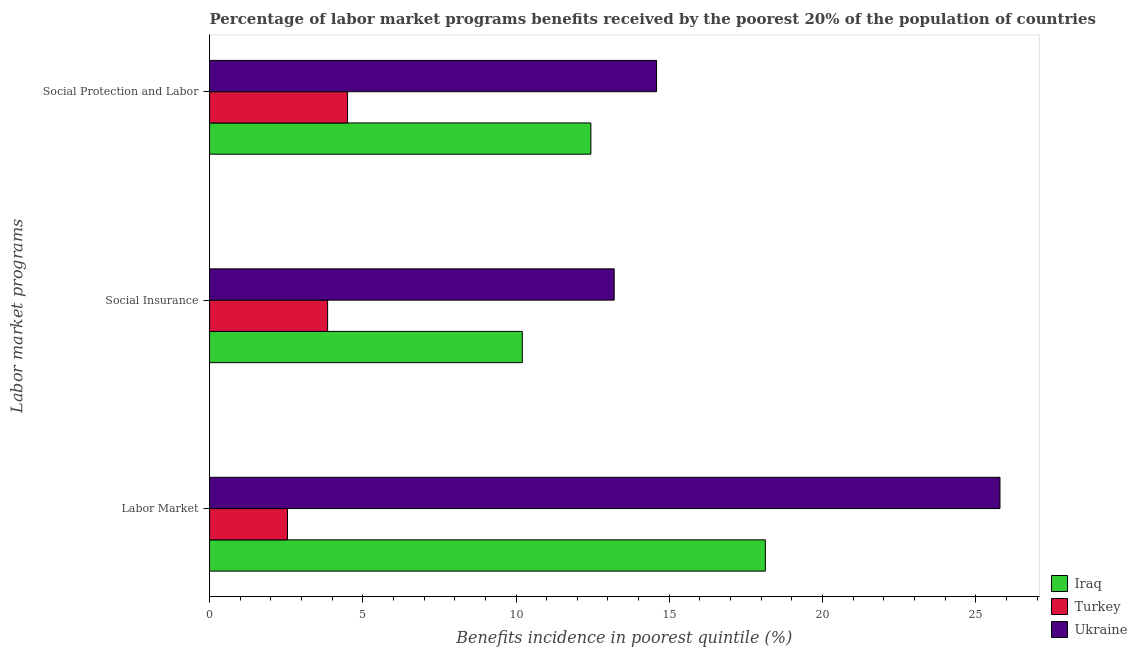How many different coloured bars are there?
Ensure brevity in your answer.  3. Are the number of bars per tick equal to the number of legend labels?
Offer a very short reply. Yes. Are the number of bars on each tick of the Y-axis equal?
Give a very brief answer. Yes. How many bars are there on the 1st tick from the top?
Your answer should be very brief. 3. What is the label of the 2nd group of bars from the top?
Your answer should be compact. Social Insurance. What is the percentage of benefits received due to social insurance programs in Ukraine?
Make the answer very short. 13.2. Across all countries, what is the maximum percentage of benefits received due to social insurance programs?
Provide a short and direct response. 13.2. Across all countries, what is the minimum percentage of benefits received due to labor market programs?
Provide a succinct answer. 2.54. In which country was the percentage of benefits received due to social insurance programs maximum?
Provide a short and direct response. Ukraine. In which country was the percentage of benefits received due to social insurance programs minimum?
Your response must be concise. Turkey. What is the total percentage of benefits received due to labor market programs in the graph?
Your answer should be compact. 46.47. What is the difference between the percentage of benefits received due to social protection programs in Iraq and that in Turkey?
Your response must be concise. 7.94. What is the difference between the percentage of benefits received due to labor market programs in Ukraine and the percentage of benefits received due to social insurance programs in Iraq?
Ensure brevity in your answer.  15.59. What is the average percentage of benefits received due to social insurance programs per country?
Provide a succinct answer. 9.09. What is the difference between the percentage of benefits received due to social insurance programs and percentage of benefits received due to social protection programs in Iraq?
Ensure brevity in your answer.  -2.24. In how many countries, is the percentage of benefits received due to social protection programs greater than 26 %?
Make the answer very short. 0. What is the ratio of the percentage of benefits received due to social insurance programs in Iraq to that in Ukraine?
Your answer should be compact. 0.77. Is the percentage of benefits received due to social protection programs in Turkey less than that in Ukraine?
Your answer should be very brief. Yes. Is the difference between the percentage of benefits received due to social protection programs in Ukraine and Iraq greater than the difference between the percentage of benefits received due to social insurance programs in Ukraine and Iraq?
Your response must be concise. No. What is the difference between the highest and the second highest percentage of benefits received due to labor market programs?
Your answer should be very brief. 7.65. What is the difference between the highest and the lowest percentage of benefits received due to social protection programs?
Offer a terse response. 10.08. What does the 1st bar from the top in Labor Market represents?
Provide a short and direct response. Ukraine. How many bars are there?
Offer a terse response. 9. Are all the bars in the graph horizontal?
Offer a terse response. Yes. Does the graph contain any zero values?
Keep it short and to the point. No. Where does the legend appear in the graph?
Offer a very short reply. Bottom right. How are the legend labels stacked?
Your answer should be very brief. Vertical. What is the title of the graph?
Your answer should be very brief. Percentage of labor market programs benefits received by the poorest 20% of the population of countries. What is the label or title of the X-axis?
Offer a terse response. Benefits incidence in poorest quintile (%). What is the label or title of the Y-axis?
Make the answer very short. Labor market programs. What is the Benefits incidence in poorest quintile (%) of Iraq in Labor Market?
Offer a terse response. 18.14. What is the Benefits incidence in poorest quintile (%) of Turkey in Labor Market?
Keep it short and to the point. 2.54. What is the Benefits incidence in poorest quintile (%) in Ukraine in Labor Market?
Provide a short and direct response. 25.79. What is the Benefits incidence in poorest quintile (%) of Iraq in Social Insurance?
Offer a terse response. 10.21. What is the Benefits incidence in poorest quintile (%) of Turkey in Social Insurance?
Give a very brief answer. 3.85. What is the Benefits incidence in poorest quintile (%) in Ukraine in Social Insurance?
Provide a succinct answer. 13.2. What is the Benefits incidence in poorest quintile (%) of Iraq in Social Protection and Labor?
Ensure brevity in your answer.  12.44. What is the Benefits incidence in poorest quintile (%) of Turkey in Social Protection and Labor?
Your response must be concise. 4.5. What is the Benefits incidence in poorest quintile (%) in Ukraine in Social Protection and Labor?
Your response must be concise. 14.59. Across all Labor market programs, what is the maximum Benefits incidence in poorest quintile (%) of Iraq?
Provide a short and direct response. 18.14. Across all Labor market programs, what is the maximum Benefits incidence in poorest quintile (%) in Turkey?
Ensure brevity in your answer.  4.5. Across all Labor market programs, what is the maximum Benefits incidence in poorest quintile (%) of Ukraine?
Ensure brevity in your answer.  25.79. Across all Labor market programs, what is the minimum Benefits incidence in poorest quintile (%) of Iraq?
Your answer should be compact. 10.21. Across all Labor market programs, what is the minimum Benefits incidence in poorest quintile (%) of Turkey?
Ensure brevity in your answer.  2.54. Across all Labor market programs, what is the minimum Benefits incidence in poorest quintile (%) in Ukraine?
Make the answer very short. 13.2. What is the total Benefits incidence in poorest quintile (%) in Iraq in the graph?
Provide a succinct answer. 40.78. What is the total Benefits incidence in poorest quintile (%) in Turkey in the graph?
Keep it short and to the point. 10.9. What is the total Benefits incidence in poorest quintile (%) in Ukraine in the graph?
Offer a terse response. 53.58. What is the difference between the Benefits incidence in poorest quintile (%) of Iraq in Labor Market and that in Social Insurance?
Ensure brevity in your answer.  7.93. What is the difference between the Benefits incidence in poorest quintile (%) in Turkey in Labor Market and that in Social Insurance?
Your answer should be very brief. -1.31. What is the difference between the Benefits incidence in poorest quintile (%) of Ukraine in Labor Market and that in Social Insurance?
Ensure brevity in your answer.  12.59. What is the difference between the Benefits incidence in poorest quintile (%) in Iraq in Labor Market and that in Social Protection and Labor?
Ensure brevity in your answer.  5.69. What is the difference between the Benefits incidence in poorest quintile (%) of Turkey in Labor Market and that in Social Protection and Labor?
Your answer should be compact. -1.96. What is the difference between the Benefits incidence in poorest quintile (%) in Ukraine in Labor Market and that in Social Protection and Labor?
Your response must be concise. 11.21. What is the difference between the Benefits incidence in poorest quintile (%) of Iraq in Social Insurance and that in Social Protection and Labor?
Your answer should be compact. -2.24. What is the difference between the Benefits incidence in poorest quintile (%) of Turkey in Social Insurance and that in Social Protection and Labor?
Give a very brief answer. -0.65. What is the difference between the Benefits incidence in poorest quintile (%) in Ukraine in Social Insurance and that in Social Protection and Labor?
Keep it short and to the point. -1.38. What is the difference between the Benefits incidence in poorest quintile (%) of Iraq in Labor Market and the Benefits incidence in poorest quintile (%) of Turkey in Social Insurance?
Offer a terse response. 14.28. What is the difference between the Benefits incidence in poorest quintile (%) of Iraq in Labor Market and the Benefits incidence in poorest quintile (%) of Ukraine in Social Insurance?
Offer a very short reply. 4.93. What is the difference between the Benefits incidence in poorest quintile (%) in Turkey in Labor Market and the Benefits incidence in poorest quintile (%) in Ukraine in Social Insurance?
Your answer should be compact. -10.66. What is the difference between the Benefits incidence in poorest quintile (%) of Iraq in Labor Market and the Benefits incidence in poorest quintile (%) of Turkey in Social Protection and Labor?
Offer a very short reply. 13.63. What is the difference between the Benefits incidence in poorest quintile (%) of Iraq in Labor Market and the Benefits incidence in poorest quintile (%) of Ukraine in Social Protection and Labor?
Ensure brevity in your answer.  3.55. What is the difference between the Benefits incidence in poorest quintile (%) of Turkey in Labor Market and the Benefits incidence in poorest quintile (%) of Ukraine in Social Protection and Labor?
Provide a short and direct response. -12.04. What is the difference between the Benefits incidence in poorest quintile (%) of Iraq in Social Insurance and the Benefits incidence in poorest quintile (%) of Turkey in Social Protection and Labor?
Offer a terse response. 5.7. What is the difference between the Benefits incidence in poorest quintile (%) in Iraq in Social Insurance and the Benefits incidence in poorest quintile (%) in Ukraine in Social Protection and Labor?
Ensure brevity in your answer.  -4.38. What is the difference between the Benefits incidence in poorest quintile (%) in Turkey in Social Insurance and the Benefits incidence in poorest quintile (%) in Ukraine in Social Protection and Labor?
Keep it short and to the point. -10.73. What is the average Benefits incidence in poorest quintile (%) of Iraq per Labor market programs?
Ensure brevity in your answer.  13.59. What is the average Benefits incidence in poorest quintile (%) in Turkey per Labor market programs?
Make the answer very short. 3.63. What is the average Benefits incidence in poorest quintile (%) in Ukraine per Labor market programs?
Provide a succinct answer. 17.86. What is the difference between the Benefits incidence in poorest quintile (%) of Iraq and Benefits incidence in poorest quintile (%) of Turkey in Labor Market?
Your answer should be compact. 15.59. What is the difference between the Benefits incidence in poorest quintile (%) in Iraq and Benefits incidence in poorest quintile (%) in Ukraine in Labor Market?
Provide a succinct answer. -7.65. What is the difference between the Benefits incidence in poorest quintile (%) of Turkey and Benefits incidence in poorest quintile (%) of Ukraine in Labor Market?
Offer a terse response. -23.25. What is the difference between the Benefits incidence in poorest quintile (%) of Iraq and Benefits incidence in poorest quintile (%) of Turkey in Social Insurance?
Ensure brevity in your answer.  6.35. What is the difference between the Benefits incidence in poorest quintile (%) in Iraq and Benefits incidence in poorest quintile (%) in Ukraine in Social Insurance?
Your answer should be very brief. -3. What is the difference between the Benefits incidence in poorest quintile (%) in Turkey and Benefits incidence in poorest quintile (%) in Ukraine in Social Insurance?
Give a very brief answer. -9.35. What is the difference between the Benefits incidence in poorest quintile (%) of Iraq and Benefits incidence in poorest quintile (%) of Turkey in Social Protection and Labor?
Provide a short and direct response. 7.94. What is the difference between the Benefits incidence in poorest quintile (%) in Iraq and Benefits incidence in poorest quintile (%) in Ukraine in Social Protection and Labor?
Make the answer very short. -2.14. What is the difference between the Benefits incidence in poorest quintile (%) in Turkey and Benefits incidence in poorest quintile (%) in Ukraine in Social Protection and Labor?
Your answer should be compact. -10.08. What is the ratio of the Benefits incidence in poorest quintile (%) of Iraq in Labor Market to that in Social Insurance?
Your answer should be compact. 1.78. What is the ratio of the Benefits incidence in poorest quintile (%) in Turkey in Labor Market to that in Social Insurance?
Ensure brevity in your answer.  0.66. What is the ratio of the Benefits incidence in poorest quintile (%) in Ukraine in Labor Market to that in Social Insurance?
Make the answer very short. 1.95. What is the ratio of the Benefits incidence in poorest quintile (%) in Iraq in Labor Market to that in Social Protection and Labor?
Make the answer very short. 1.46. What is the ratio of the Benefits incidence in poorest quintile (%) of Turkey in Labor Market to that in Social Protection and Labor?
Your response must be concise. 0.56. What is the ratio of the Benefits incidence in poorest quintile (%) in Ukraine in Labor Market to that in Social Protection and Labor?
Offer a very short reply. 1.77. What is the ratio of the Benefits incidence in poorest quintile (%) in Iraq in Social Insurance to that in Social Protection and Labor?
Keep it short and to the point. 0.82. What is the ratio of the Benefits incidence in poorest quintile (%) in Turkey in Social Insurance to that in Social Protection and Labor?
Provide a succinct answer. 0.86. What is the ratio of the Benefits incidence in poorest quintile (%) of Ukraine in Social Insurance to that in Social Protection and Labor?
Give a very brief answer. 0.91. What is the difference between the highest and the second highest Benefits incidence in poorest quintile (%) of Iraq?
Make the answer very short. 5.69. What is the difference between the highest and the second highest Benefits incidence in poorest quintile (%) of Turkey?
Give a very brief answer. 0.65. What is the difference between the highest and the second highest Benefits incidence in poorest quintile (%) of Ukraine?
Offer a very short reply. 11.21. What is the difference between the highest and the lowest Benefits incidence in poorest quintile (%) of Iraq?
Your answer should be compact. 7.93. What is the difference between the highest and the lowest Benefits incidence in poorest quintile (%) in Turkey?
Your response must be concise. 1.96. What is the difference between the highest and the lowest Benefits incidence in poorest quintile (%) of Ukraine?
Ensure brevity in your answer.  12.59. 